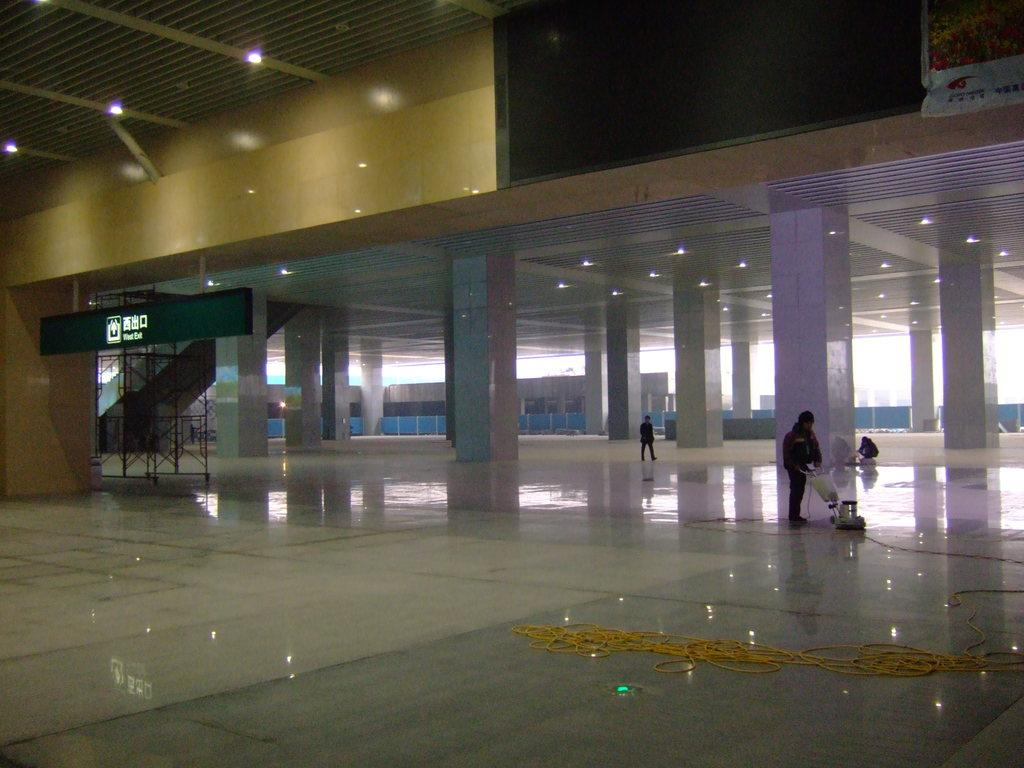How many people are on the floor in the image? There are three people on the floor in the image. What objects can be seen in the image that are related to suspension or support? Ropes, pillars, and rods are visible in the image. What items in the image might indicate the presence of an event or gathering? There is a name board and a banner in the image. What type of lighting is present in the image? There are lights in the image. Can you describe any unspecified objects in the image? There are some unspecified objects in the image, but their purpose or appearance cannot be determined from the provided facts. What type of hen can be seen interacting with the banner in the image? There is no hen present in the image; it only features three people, ropes, pillars, rods, lights, a name board, a banner, and some unspecified objects. What is the name of the daughter of the person whose name is on the name board in the image? There is no information about the person whose name is on the name board, nor any indication of a daughter, so this information cannot be determined from the image. 